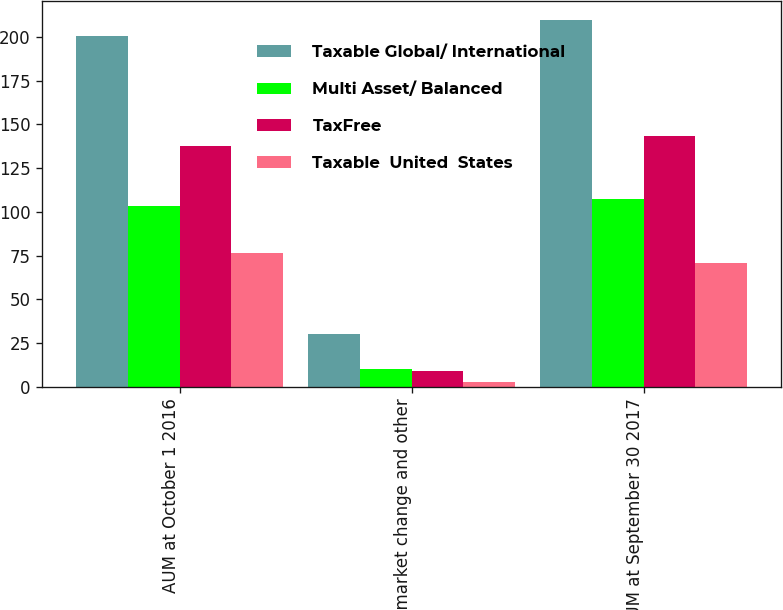<chart> <loc_0><loc_0><loc_500><loc_500><stacked_bar_chart><ecel><fcel>AUM at October 1 2016<fcel>Net market change and other<fcel>AUM at September 30 2017<nl><fcel>Taxable Global/ International<fcel>200.4<fcel>30.2<fcel>209.8<nl><fcel>Multi Asset/ Balanced<fcel>103.3<fcel>10<fcel>107.2<nl><fcel>TaxFree<fcel>137.4<fcel>9.3<fcel>143.3<nl><fcel>Taxable  United  States<fcel>76.5<fcel>2.8<fcel>71<nl></chart> 